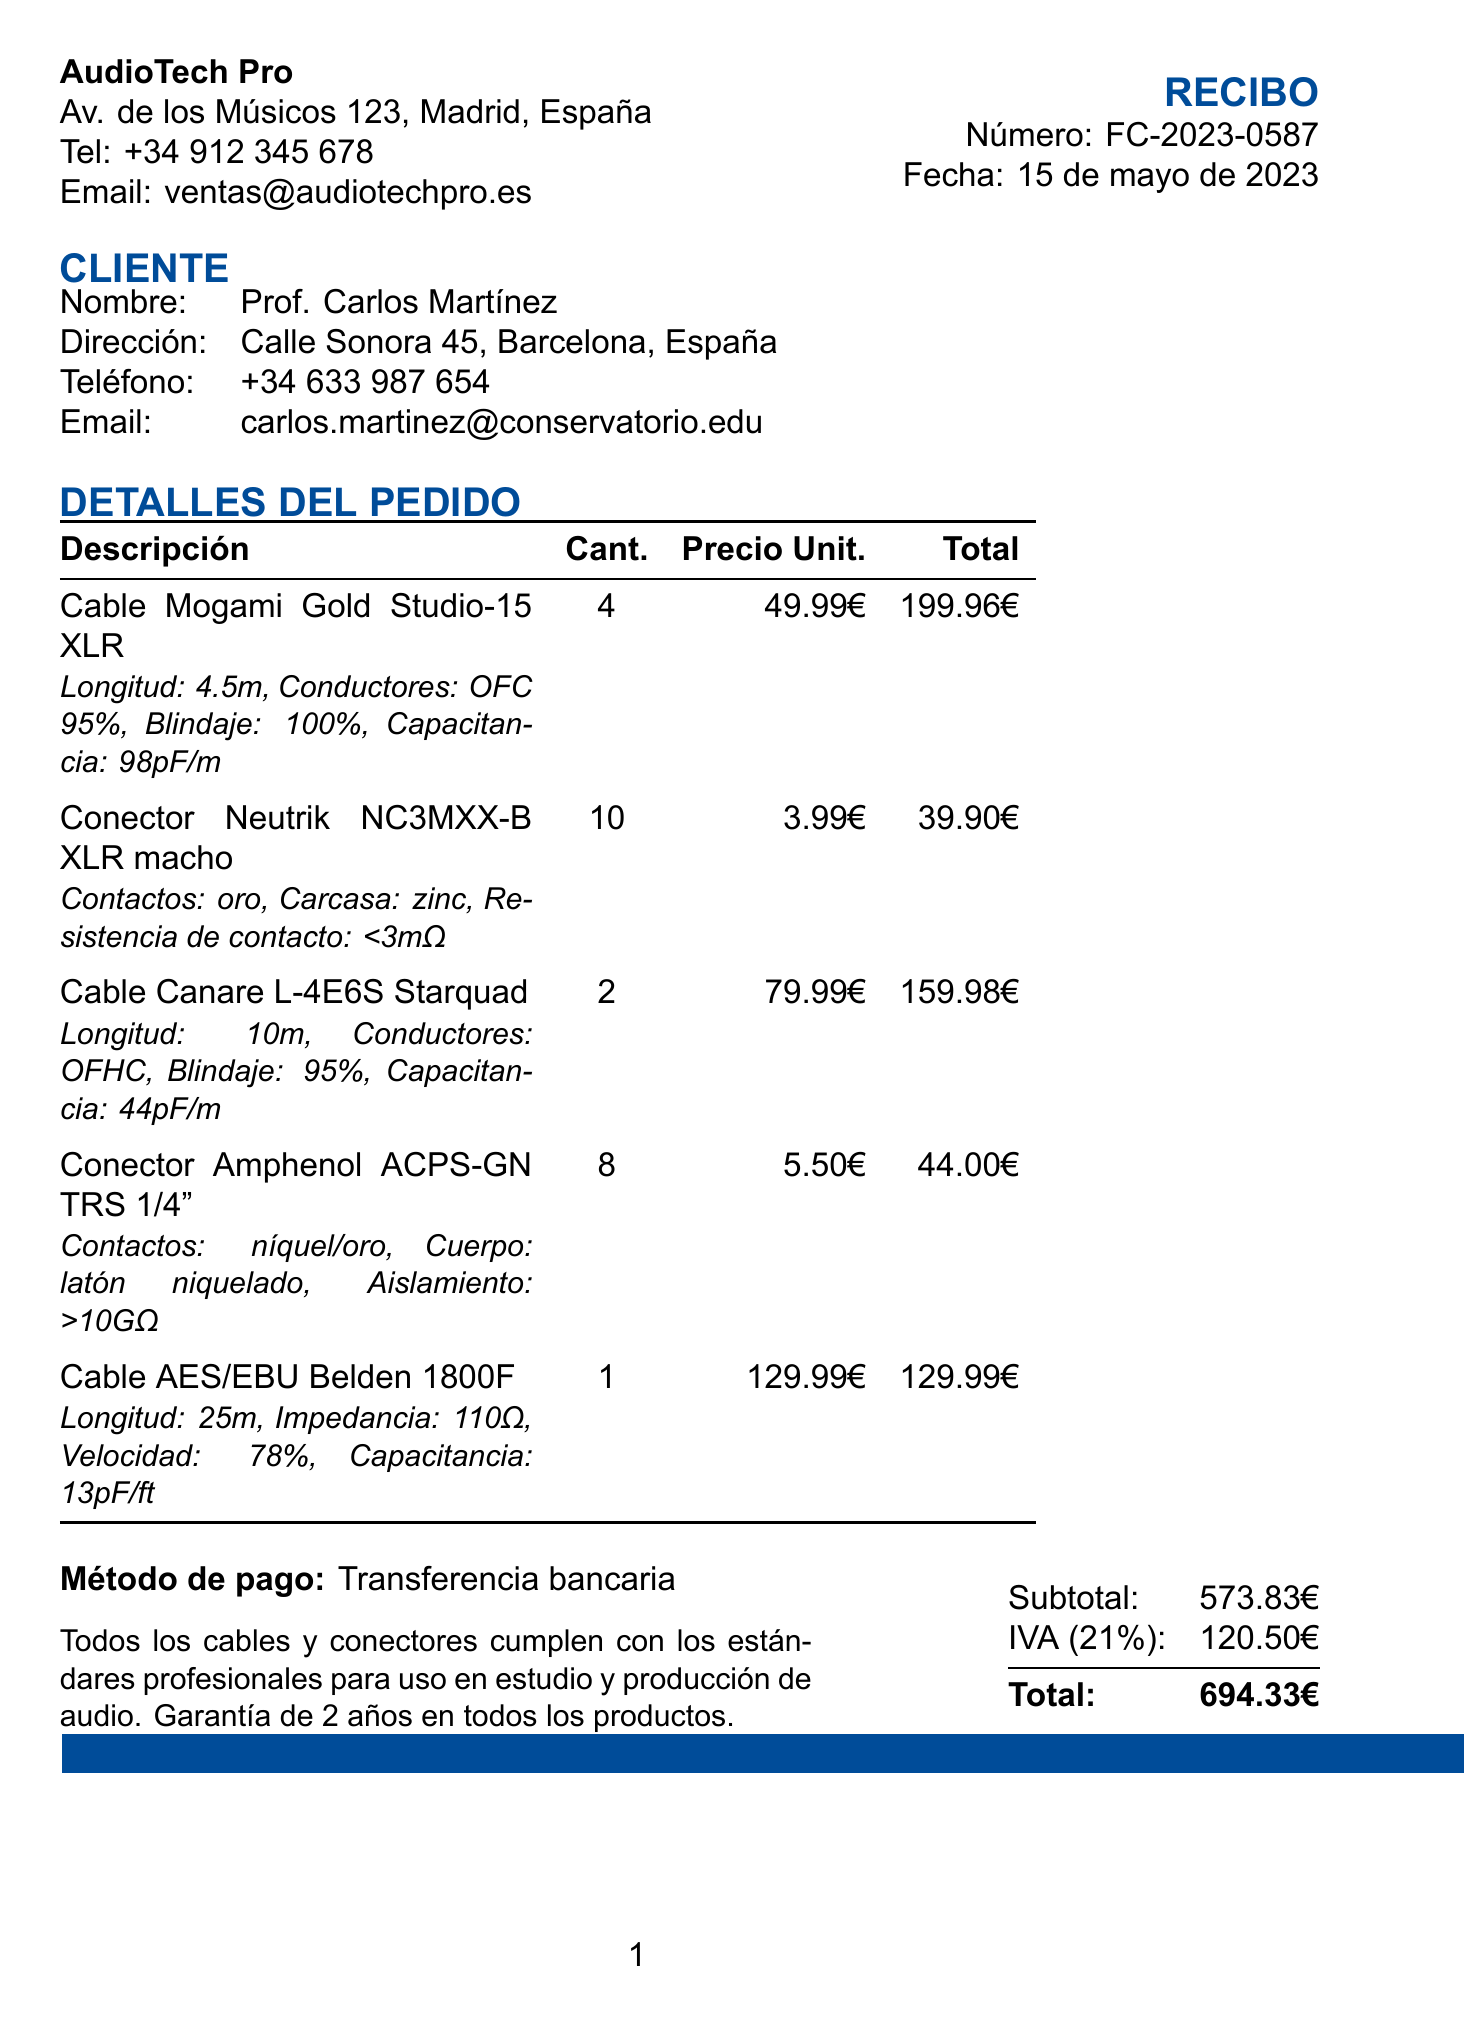¿Qué número tiene el recibo? El número del recibo se encuentra en la parte superior del documento, específicamente marcado como "Número".
Answer: FC-2023-0587 ¿Quién es el vendedor? El nombre del vendedor se menciona en la parte superior del documento junto a su información de contacto.
Answer: AudioTech Pro ¿Cuál es la fecha de compra? La fecha de compra está indicada en el encabezado del recibo, al lado del número del recibo.
Answer: 15 de mayo de 2023 ¿Cuál es el total de la compra? El total se presenta en la parte inferior del recibo, junto a medidas fiscales.
Answer: 694.33€ ¿Cuántos cables Mogami Gold Studio-15 XLR se compraron? La cantidad comprada está indicada en la tabla de detalles del pedido, junto a la descripción del producto.
Answer: 4 ¿Cuál es el precio unitario del conector Neutrik NC3MXX-B XLR macho? El precio por unidad está especificado en la tabla de detalles del pedido.
Answer: 3.99€ ¿El recibo incluye garantía para los productos? La nota al final del recibo menciona la garantía de los productos.
Answer: Sí ¿Cuál es el método de pago utilizado? El método de pago se encuentra en la parte inferior del recibo, justo antes de los totales.
Answer: Transferencia bancaria ¿Cuántos conectores Amphenol ACPS-GN TRS 1/4" se compraron? La cantidad comprada está indicada en la tabla de detalles del pedido, en la fila correspondiente.
Answer: 8 ¿Qué es la capacitancia del Cable AES/EBU Belden 1800F? La especificación técnica se muestra en la tabla de detalles del pedido, en la fila correspondiente al cable.
Answer: 13pF/ft 